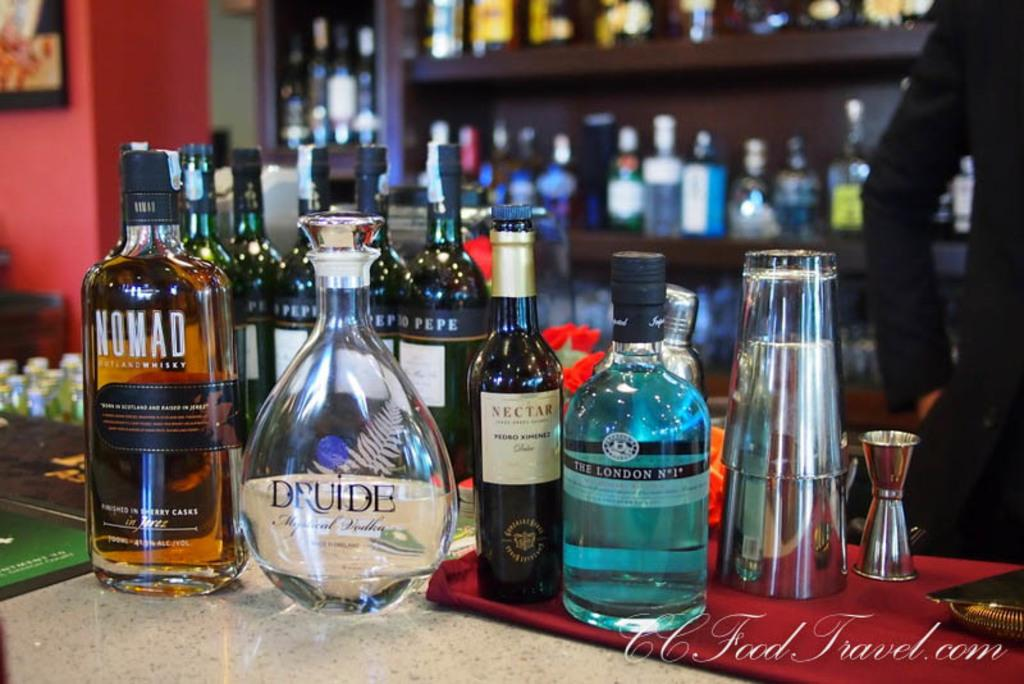<image>
Offer a succinct explanation of the picture presented. A bottle of Druide is surrounded by other bottles. 